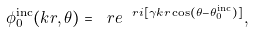Convert formula to latex. <formula><loc_0><loc_0><loc_500><loc_500>\phi _ { 0 } ^ { \text {inc} } ( k r , \theta ) = \ r e ^ { \ r i [ \gamma k r \cos ( \theta - \theta _ { 0 } ^ { \text {inc} } ) ] } ,</formula> 